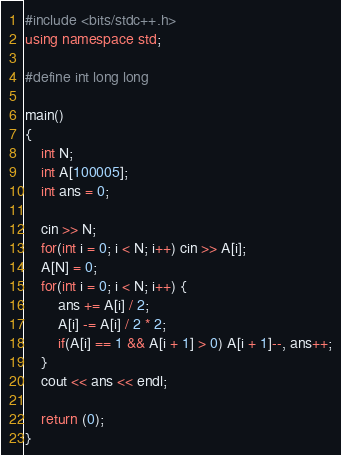<code> <loc_0><loc_0><loc_500><loc_500><_C++_>#include <bits/stdc++.h>
using namespace std;

#define int long long

main()
{
    int N;
    int A[100005];
    int ans = 0;

    cin >> N;
    for(int i = 0; i < N; i++) cin >> A[i];
    A[N] = 0;
    for(int i = 0; i < N; i++) {
        ans += A[i] / 2;
        A[i] -= A[i] / 2 * 2;
        if(A[i] == 1 && A[i + 1] > 0) A[i + 1]--, ans++;
    }
    cout << ans << endl;

    return (0);
}</code> 